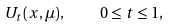Convert formula to latex. <formula><loc_0><loc_0><loc_500><loc_500>U _ { t } ( x , \mu ) , \quad 0 \leq t \leq 1 ,</formula> 